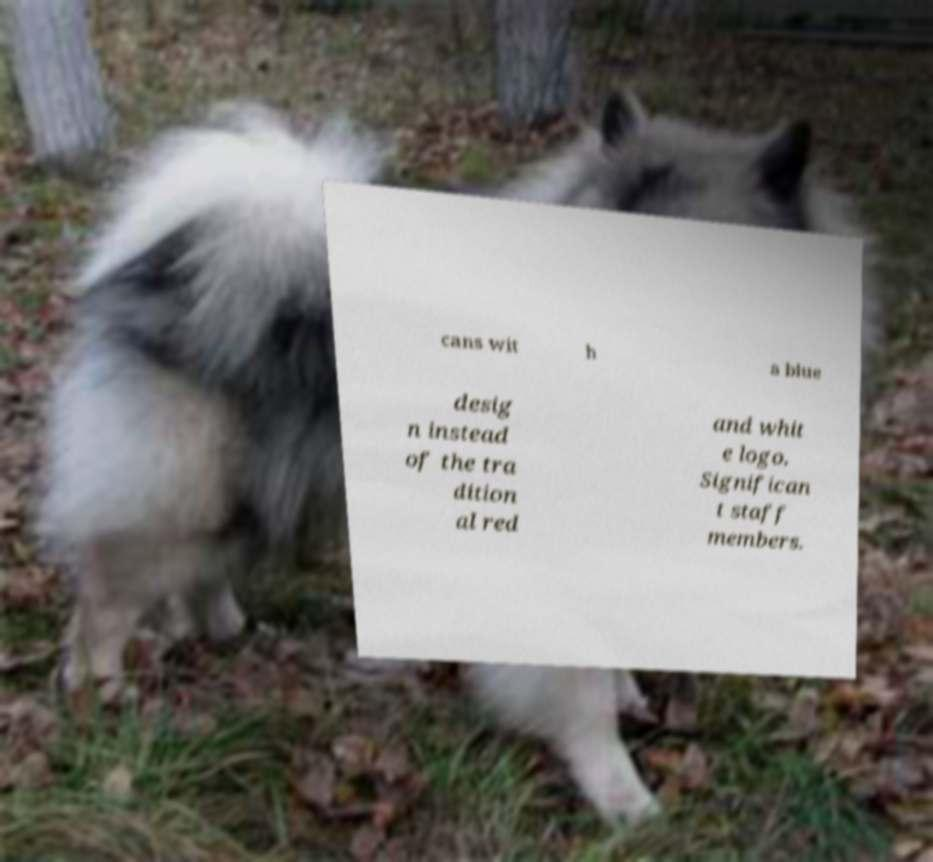Please read and relay the text visible in this image. What does it say? cans wit h a blue desig n instead of the tra dition al red and whit e logo. Significan t staff members. 